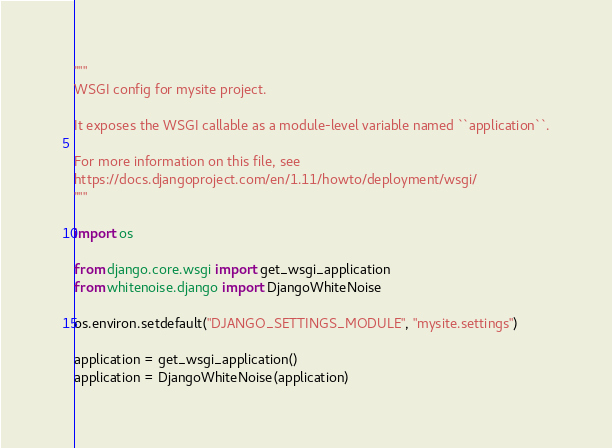Convert code to text. <code><loc_0><loc_0><loc_500><loc_500><_Python_>"""
WSGI config for mysite project.

It exposes the WSGI callable as a module-level variable named ``application``.

For more information on this file, see
https://docs.djangoproject.com/en/1.11/howto/deployment/wsgi/
"""

import os

from django.core.wsgi import get_wsgi_application
from whitenoise.django import DjangoWhiteNoise

os.environ.setdefault("DJANGO_SETTINGS_MODULE", "mysite.settings")

application = get_wsgi_application()
application = DjangoWhiteNoise(application)</code> 